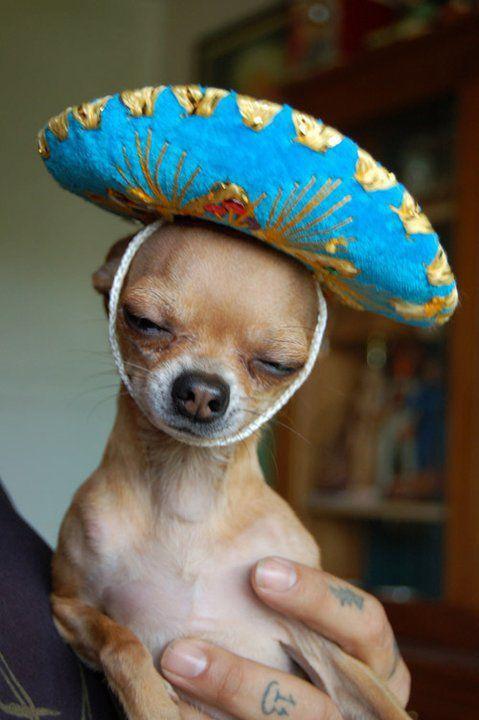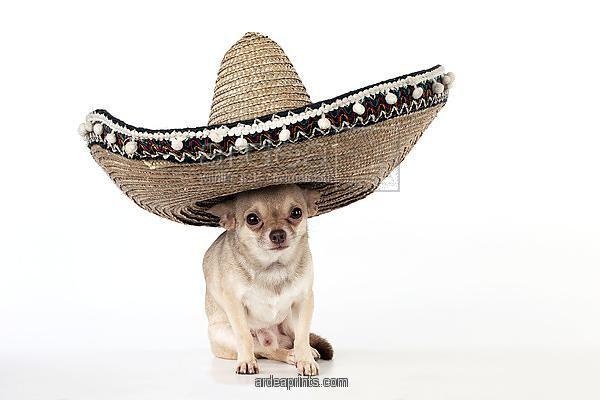The first image is the image on the left, the second image is the image on the right. Examine the images to the left and right. Is the description "Each image shows a chihuahua dog wearing a sombrero on top of its head." accurate? Answer yes or no. Yes. The first image is the image on the left, the second image is the image on the right. Evaluate the accuracy of this statement regarding the images: "There are two chihuahuas wearing sombreros on top of their heads.". Is it true? Answer yes or no. Yes. 